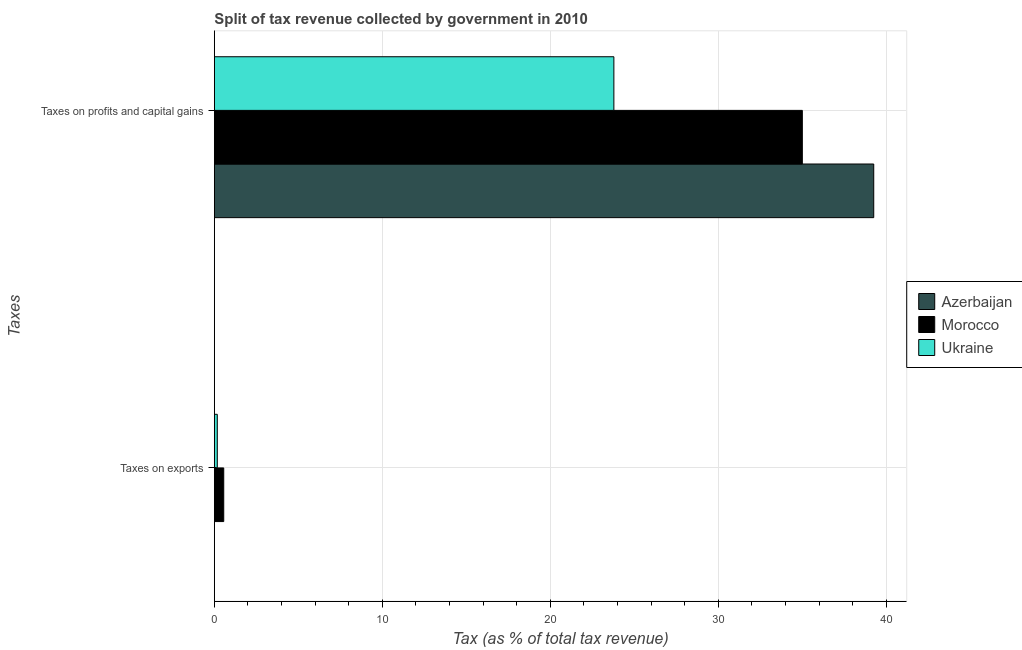How many bars are there on the 1st tick from the bottom?
Make the answer very short. 3. What is the label of the 1st group of bars from the top?
Offer a terse response. Taxes on profits and capital gains. What is the percentage of revenue obtained from taxes on profits and capital gains in Morocco?
Keep it short and to the point. 35. Across all countries, what is the maximum percentage of revenue obtained from taxes on profits and capital gains?
Make the answer very short. 39.25. Across all countries, what is the minimum percentage of revenue obtained from taxes on profits and capital gains?
Your response must be concise. 23.78. In which country was the percentage of revenue obtained from taxes on profits and capital gains maximum?
Give a very brief answer. Azerbaijan. In which country was the percentage of revenue obtained from taxes on profits and capital gains minimum?
Your answer should be very brief. Ukraine. What is the total percentage of revenue obtained from taxes on profits and capital gains in the graph?
Give a very brief answer. 98.04. What is the difference between the percentage of revenue obtained from taxes on profits and capital gains in Morocco and that in Azerbaijan?
Your answer should be compact. -4.25. What is the difference between the percentage of revenue obtained from taxes on exports in Ukraine and the percentage of revenue obtained from taxes on profits and capital gains in Azerbaijan?
Your response must be concise. -39.08. What is the average percentage of revenue obtained from taxes on profits and capital gains per country?
Offer a very short reply. 32.68. What is the difference between the percentage of revenue obtained from taxes on profits and capital gains and percentage of revenue obtained from taxes on exports in Ukraine?
Provide a short and direct response. 23.61. What is the ratio of the percentage of revenue obtained from taxes on profits and capital gains in Azerbaijan to that in Morocco?
Your answer should be compact. 1.12. Is the percentage of revenue obtained from taxes on exports in Morocco less than that in Azerbaijan?
Your answer should be compact. No. In how many countries, is the percentage of revenue obtained from taxes on profits and capital gains greater than the average percentage of revenue obtained from taxes on profits and capital gains taken over all countries?
Ensure brevity in your answer.  2. What does the 2nd bar from the top in Taxes on exports represents?
Keep it short and to the point. Morocco. What does the 3rd bar from the bottom in Taxes on exports represents?
Give a very brief answer. Ukraine. How many bars are there?
Provide a succinct answer. 6. What is the difference between two consecutive major ticks on the X-axis?
Give a very brief answer. 10. Are the values on the major ticks of X-axis written in scientific E-notation?
Offer a terse response. No. Does the graph contain grids?
Your answer should be very brief. Yes. Where does the legend appear in the graph?
Ensure brevity in your answer.  Center right. How are the legend labels stacked?
Offer a very short reply. Vertical. What is the title of the graph?
Your answer should be very brief. Split of tax revenue collected by government in 2010. What is the label or title of the X-axis?
Give a very brief answer. Tax (as % of total tax revenue). What is the label or title of the Y-axis?
Offer a very short reply. Taxes. What is the Tax (as % of total tax revenue) of Azerbaijan in Taxes on exports?
Your response must be concise. 0. What is the Tax (as % of total tax revenue) of Morocco in Taxes on exports?
Make the answer very short. 0.56. What is the Tax (as % of total tax revenue) in Ukraine in Taxes on exports?
Offer a terse response. 0.18. What is the Tax (as % of total tax revenue) of Azerbaijan in Taxes on profits and capital gains?
Give a very brief answer. 39.25. What is the Tax (as % of total tax revenue) of Morocco in Taxes on profits and capital gains?
Your answer should be very brief. 35. What is the Tax (as % of total tax revenue) of Ukraine in Taxes on profits and capital gains?
Provide a short and direct response. 23.78. Across all Taxes, what is the maximum Tax (as % of total tax revenue) of Azerbaijan?
Your answer should be compact. 39.25. Across all Taxes, what is the maximum Tax (as % of total tax revenue) in Morocco?
Your response must be concise. 35. Across all Taxes, what is the maximum Tax (as % of total tax revenue) in Ukraine?
Provide a short and direct response. 23.78. Across all Taxes, what is the minimum Tax (as % of total tax revenue) in Azerbaijan?
Give a very brief answer. 0. Across all Taxes, what is the minimum Tax (as % of total tax revenue) in Morocco?
Keep it short and to the point. 0.56. Across all Taxes, what is the minimum Tax (as % of total tax revenue) in Ukraine?
Provide a succinct answer. 0.18. What is the total Tax (as % of total tax revenue) in Azerbaijan in the graph?
Give a very brief answer. 39.26. What is the total Tax (as % of total tax revenue) of Morocco in the graph?
Make the answer very short. 35.56. What is the total Tax (as % of total tax revenue) of Ukraine in the graph?
Provide a succinct answer. 23.96. What is the difference between the Tax (as % of total tax revenue) of Azerbaijan in Taxes on exports and that in Taxes on profits and capital gains?
Ensure brevity in your answer.  -39.25. What is the difference between the Tax (as % of total tax revenue) of Morocco in Taxes on exports and that in Taxes on profits and capital gains?
Give a very brief answer. -34.44. What is the difference between the Tax (as % of total tax revenue) of Ukraine in Taxes on exports and that in Taxes on profits and capital gains?
Provide a succinct answer. -23.61. What is the difference between the Tax (as % of total tax revenue) of Azerbaijan in Taxes on exports and the Tax (as % of total tax revenue) of Morocco in Taxes on profits and capital gains?
Make the answer very short. -35. What is the difference between the Tax (as % of total tax revenue) in Azerbaijan in Taxes on exports and the Tax (as % of total tax revenue) in Ukraine in Taxes on profits and capital gains?
Offer a terse response. -23.78. What is the difference between the Tax (as % of total tax revenue) of Morocco in Taxes on exports and the Tax (as % of total tax revenue) of Ukraine in Taxes on profits and capital gains?
Provide a short and direct response. -23.22. What is the average Tax (as % of total tax revenue) in Azerbaijan per Taxes?
Make the answer very short. 19.63. What is the average Tax (as % of total tax revenue) in Morocco per Taxes?
Keep it short and to the point. 17.78. What is the average Tax (as % of total tax revenue) in Ukraine per Taxes?
Provide a succinct answer. 11.98. What is the difference between the Tax (as % of total tax revenue) in Azerbaijan and Tax (as % of total tax revenue) in Morocco in Taxes on exports?
Keep it short and to the point. -0.55. What is the difference between the Tax (as % of total tax revenue) in Azerbaijan and Tax (as % of total tax revenue) in Ukraine in Taxes on exports?
Keep it short and to the point. -0.17. What is the difference between the Tax (as % of total tax revenue) of Morocco and Tax (as % of total tax revenue) of Ukraine in Taxes on exports?
Your answer should be compact. 0.38. What is the difference between the Tax (as % of total tax revenue) of Azerbaijan and Tax (as % of total tax revenue) of Morocco in Taxes on profits and capital gains?
Ensure brevity in your answer.  4.25. What is the difference between the Tax (as % of total tax revenue) of Azerbaijan and Tax (as % of total tax revenue) of Ukraine in Taxes on profits and capital gains?
Ensure brevity in your answer.  15.47. What is the difference between the Tax (as % of total tax revenue) in Morocco and Tax (as % of total tax revenue) in Ukraine in Taxes on profits and capital gains?
Offer a very short reply. 11.22. What is the ratio of the Tax (as % of total tax revenue) in Morocco in Taxes on exports to that in Taxes on profits and capital gains?
Your answer should be very brief. 0.02. What is the ratio of the Tax (as % of total tax revenue) in Ukraine in Taxes on exports to that in Taxes on profits and capital gains?
Provide a short and direct response. 0.01. What is the difference between the highest and the second highest Tax (as % of total tax revenue) in Azerbaijan?
Provide a succinct answer. 39.25. What is the difference between the highest and the second highest Tax (as % of total tax revenue) of Morocco?
Your answer should be compact. 34.44. What is the difference between the highest and the second highest Tax (as % of total tax revenue) of Ukraine?
Your answer should be very brief. 23.61. What is the difference between the highest and the lowest Tax (as % of total tax revenue) of Azerbaijan?
Keep it short and to the point. 39.25. What is the difference between the highest and the lowest Tax (as % of total tax revenue) of Morocco?
Offer a terse response. 34.44. What is the difference between the highest and the lowest Tax (as % of total tax revenue) in Ukraine?
Offer a very short reply. 23.61. 